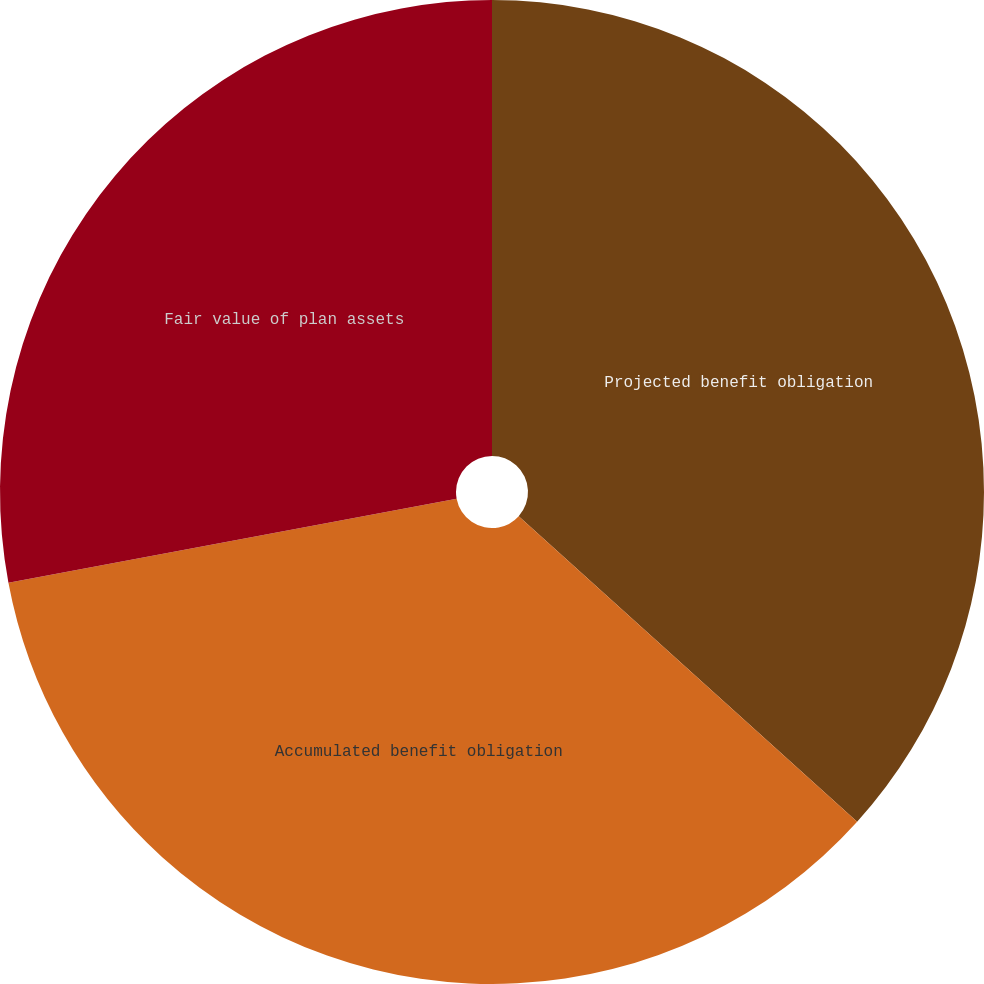Convert chart to OTSL. <chart><loc_0><loc_0><loc_500><loc_500><pie_chart><fcel>Projected benefit obligation<fcel>Accumulated benefit obligation<fcel>Fair value of plan assets<nl><fcel>36.69%<fcel>35.36%<fcel>27.95%<nl></chart> 